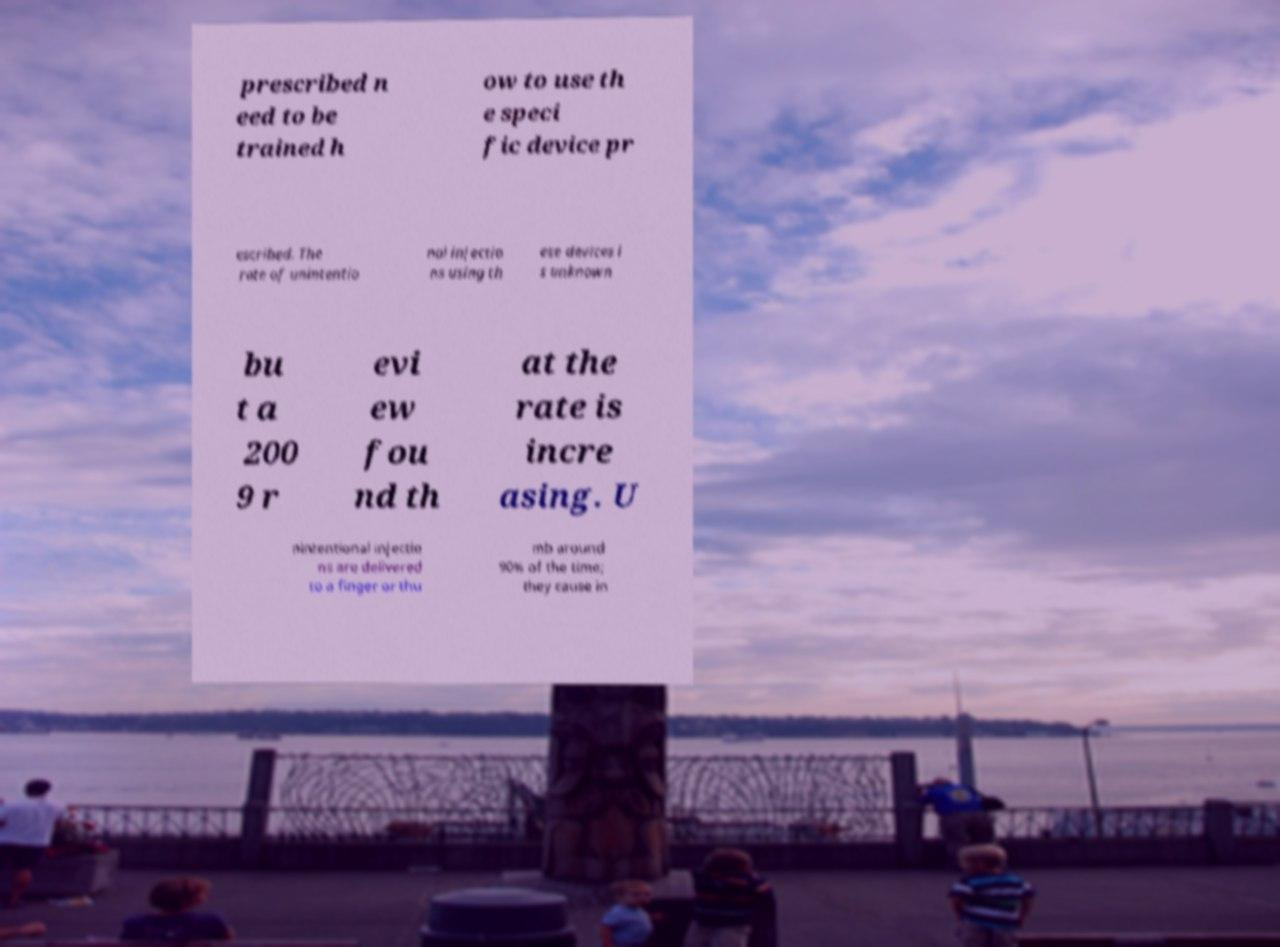There's text embedded in this image that I need extracted. Can you transcribe it verbatim? prescribed n eed to be trained h ow to use th e speci fic device pr escribed. The rate of unintentio nal injectio ns using th ese devices i s unknown bu t a 200 9 r evi ew fou nd th at the rate is incre asing. U nintentional injectio ns are delivered to a finger or thu mb around 90% of the time; they cause in 